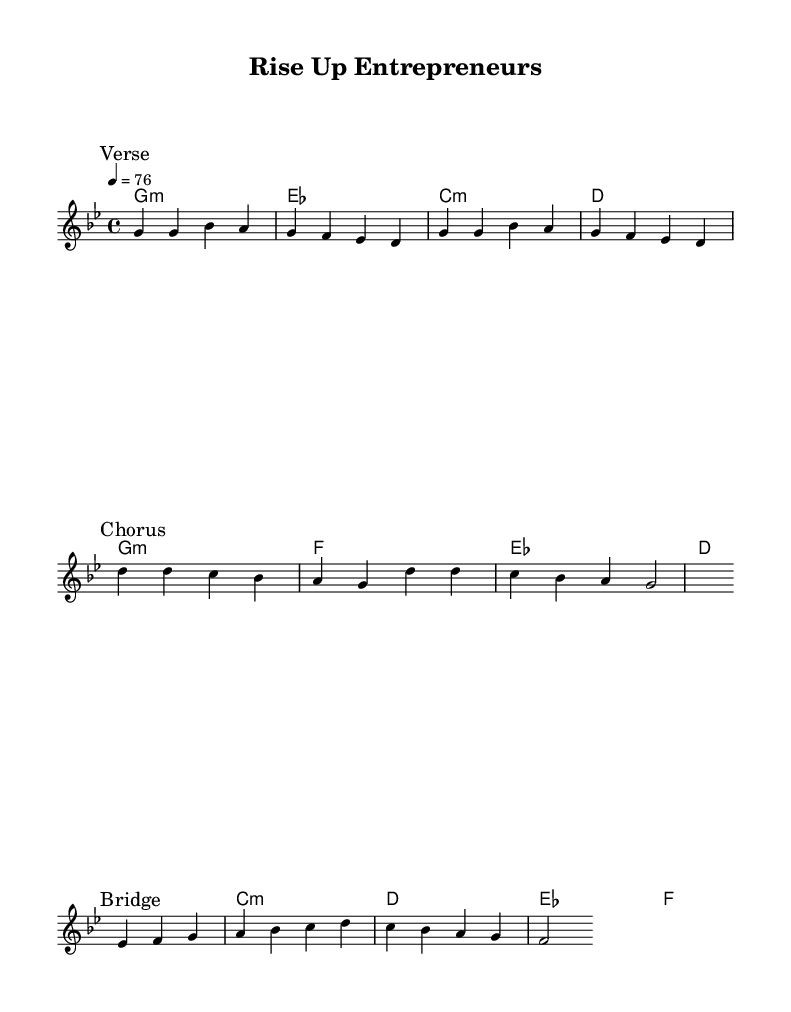What is the key signature of this music? The key signature is G minor, which includes two flats (B flat and E flat). This can be identified by looking at the key signature section of the staff at the beginning of the piece.
Answer: G minor What is the time signature of this music? The time signature is 4/4, indicating that there are four beats in each measure and the quarter note receives one beat. This can be found at the beginning of the staff, next to the key signature.
Answer: 4/4 What is the tempo marking of this piece? The tempo marking is 76 beats per minute, which is indicated in the score as "4 = 76" above the staff. This means that a quarter note is played at this speed during performance.
Answer: 76 How many measures are in the verse section? The verse section contains four measures, as indicated by counting the distinct groups of notes written out before the break.
Answer: 4 What are the lyrics of the chorus? The lyrics of the chorus are "Rise up, rise up, conscious minds, Create a world where all can shine." These are positioned directly under the melody notes designated for the chorus section.
Answer: Rise up, rise up, conscious minds, Create a world where all can shine What musical genre does this piece represent? This piece represents "Conscious reggae," a subgenre of reggae known for its social commentary and social awareness. This can be inferred from the themes and spirit expressed in the lyrics and melody.
Answer: Conscious reggae What type of chords are primarily used in this piece? The piece primarily uses minor chords, as indicated by "g1:m" and "c:m" within the chord symbols. This is a characteristic commonly found in reggae music, known for its emotive and reflective qualities.
Answer: Minor chords 